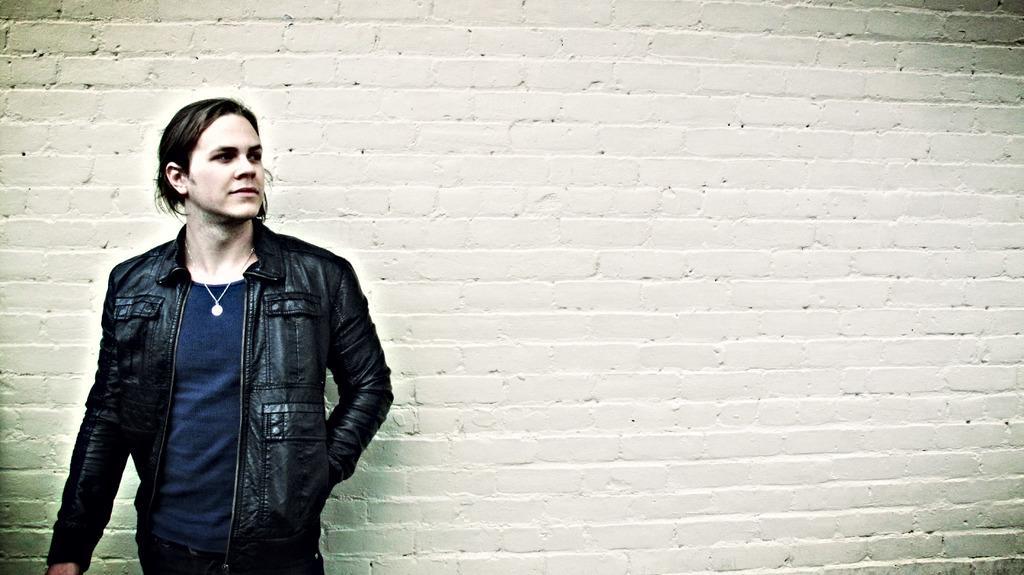Please provide a concise description of this image. On the left side of the image we can see a man standing and he is wearing a jacket. In the background there is a wall. 